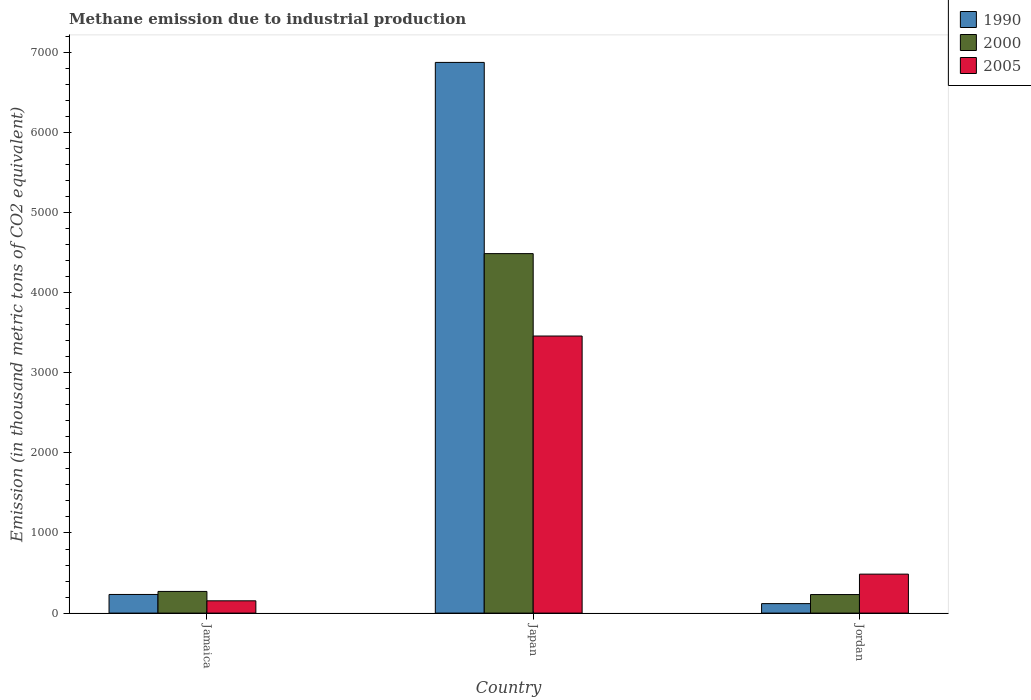How many different coloured bars are there?
Provide a short and direct response. 3. How many groups of bars are there?
Your answer should be compact. 3. How many bars are there on the 1st tick from the left?
Provide a succinct answer. 3. How many bars are there on the 1st tick from the right?
Offer a very short reply. 3. What is the label of the 1st group of bars from the left?
Your answer should be compact. Jamaica. What is the amount of methane emitted in 2000 in Jamaica?
Offer a very short reply. 270.4. Across all countries, what is the maximum amount of methane emitted in 1990?
Ensure brevity in your answer.  6873.6. Across all countries, what is the minimum amount of methane emitted in 2000?
Offer a terse response. 231.4. In which country was the amount of methane emitted in 2005 minimum?
Offer a terse response. Jamaica. What is the total amount of methane emitted in 2000 in the graph?
Ensure brevity in your answer.  4988.7. What is the difference between the amount of methane emitted in 2000 in Japan and that in Jordan?
Your answer should be compact. 4255.5. What is the difference between the amount of methane emitted in 1990 in Jordan and the amount of methane emitted in 2005 in Japan?
Make the answer very short. -3339.9. What is the average amount of methane emitted in 2005 per country?
Offer a very short reply. 1365.97. What is the difference between the amount of methane emitted of/in 2005 and amount of methane emitted of/in 1990 in Japan?
Your response must be concise. -3415.3. What is the ratio of the amount of methane emitted in 1990 in Jamaica to that in Japan?
Your answer should be very brief. 0.03. What is the difference between the highest and the second highest amount of methane emitted in 2000?
Make the answer very short. -4255.5. What is the difference between the highest and the lowest amount of methane emitted in 1990?
Provide a short and direct response. 6755.2. How many bars are there?
Your answer should be compact. 9. Are all the bars in the graph horizontal?
Ensure brevity in your answer.  No. How many countries are there in the graph?
Keep it short and to the point. 3. Does the graph contain grids?
Your response must be concise. No. Where does the legend appear in the graph?
Ensure brevity in your answer.  Top right. How many legend labels are there?
Give a very brief answer. 3. What is the title of the graph?
Ensure brevity in your answer.  Methane emission due to industrial production. Does "2014" appear as one of the legend labels in the graph?
Your response must be concise. No. What is the label or title of the Y-axis?
Ensure brevity in your answer.  Emission (in thousand metric tons of CO2 equivalent). What is the Emission (in thousand metric tons of CO2 equivalent) in 1990 in Jamaica?
Offer a terse response. 232.7. What is the Emission (in thousand metric tons of CO2 equivalent) of 2000 in Jamaica?
Provide a succinct answer. 270.4. What is the Emission (in thousand metric tons of CO2 equivalent) of 2005 in Jamaica?
Make the answer very short. 153.3. What is the Emission (in thousand metric tons of CO2 equivalent) in 1990 in Japan?
Your response must be concise. 6873.6. What is the Emission (in thousand metric tons of CO2 equivalent) in 2000 in Japan?
Your response must be concise. 4486.9. What is the Emission (in thousand metric tons of CO2 equivalent) of 2005 in Japan?
Your answer should be very brief. 3458.3. What is the Emission (in thousand metric tons of CO2 equivalent) of 1990 in Jordan?
Offer a very short reply. 118.4. What is the Emission (in thousand metric tons of CO2 equivalent) of 2000 in Jordan?
Your answer should be compact. 231.4. What is the Emission (in thousand metric tons of CO2 equivalent) of 2005 in Jordan?
Your answer should be very brief. 486.3. Across all countries, what is the maximum Emission (in thousand metric tons of CO2 equivalent) of 1990?
Provide a short and direct response. 6873.6. Across all countries, what is the maximum Emission (in thousand metric tons of CO2 equivalent) in 2000?
Offer a very short reply. 4486.9. Across all countries, what is the maximum Emission (in thousand metric tons of CO2 equivalent) of 2005?
Ensure brevity in your answer.  3458.3. Across all countries, what is the minimum Emission (in thousand metric tons of CO2 equivalent) in 1990?
Ensure brevity in your answer.  118.4. Across all countries, what is the minimum Emission (in thousand metric tons of CO2 equivalent) of 2000?
Your response must be concise. 231.4. Across all countries, what is the minimum Emission (in thousand metric tons of CO2 equivalent) of 2005?
Give a very brief answer. 153.3. What is the total Emission (in thousand metric tons of CO2 equivalent) of 1990 in the graph?
Ensure brevity in your answer.  7224.7. What is the total Emission (in thousand metric tons of CO2 equivalent) in 2000 in the graph?
Offer a very short reply. 4988.7. What is the total Emission (in thousand metric tons of CO2 equivalent) of 2005 in the graph?
Ensure brevity in your answer.  4097.9. What is the difference between the Emission (in thousand metric tons of CO2 equivalent) of 1990 in Jamaica and that in Japan?
Your answer should be compact. -6640.9. What is the difference between the Emission (in thousand metric tons of CO2 equivalent) in 2000 in Jamaica and that in Japan?
Keep it short and to the point. -4216.5. What is the difference between the Emission (in thousand metric tons of CO2 equivalent) in 2005 in Jamaica and that in Japan?
Keep it short and to the point. -3305. What is the difference between the Emission (in thousand metric tons of CO2 equivalent) in 1990 in Jamaica and that in Jordan?
Ensure brevity in your answer.  114.3. What is the difference between the Emission (in thousand metric tons of CO2 equivalent) of 2000 in Jamaica and that in Jordan?
Keep it short and to the point. 39. What is the difference between the Emission (in thousand metric tons of CO2 equivalent) of 2005 in Jamaica and that in Jordan?
Your response must be concise. -333. What is the difference between the Emission (in thousand metric tons of CO2 equivalent) of 1990 in Japan and that in Jordan?
Provide a short and direct response. 6755.2. What is the difference between the Emission (in thousand metric tons of CO2 equivalent) in 2000 in Japan and that in Jordan?
Offer a terse response. 4255.5. What is the difference between the Emission (in thousand metric tons of CO2 equivalent) in 2005 in Japan and that in Jordan?
Ensure brevity in your answer.  2972. What is the difference between the Emission (in thousand metric tons of CO2 equivalent) in 1990 in Jamaica and the Emission (in thousand metric tons of CO2 equivalent) in 2000 in Japan?
Make the answer very short. -4254.2. What is the difference between the Emission (in thousand metric tons of CO2 equivalent) in 1990 in Jamaica and the Emission (in thousand metric tons of CO2 equivalent) in 2005 in Japan?
Your response must be concise. -3225.6. What is the difference between the Emission (in thousand metric tons of CO2 equivalent) of 2000 in Jamaica and the Emission (in thousand metric tons of CO2 equivalent) of 2005 in Japan?
Give a very brief answer. -3187.9. What is the difference between the Emission (in thousand metric tons of CO2 equivalent) of 1990 in Jamaica and the Emission (in thousand metric tons of CO2 equivalent) of 2000 in Jordan?
Your response must be concise. 1.3. What is the difference between the Emission (in thousand metric tons of CO2 equivalent) in 1990 in Jamaica and the Emission (in thousand metric tons of CO2 equivalent) in 2005 in Jordan?
Provide a succinct answer. -253.6. What is the difference between the Emission (in thousand metric tons of CO2 equivalent) in 2000 in Jamaica and the Emission (in thousand metric tons of CO2 equivalent) in 2005 in Jordan?
Ensure brevity in your answer.  -215.9. What is the difference between the Emission (in thousand metric tons of CO2 equivalent) in 1990 in Japan and the Emission (in thousand metric tons of CO2 equivalent) in 2000 in Jordan?
Your response must be concise. 6642.2. What is the difference between the Emission (in thousand metric tons of CO2 equivalent) in 1990 in Japan and the Emission (in thousand metric tons of CO2 equivalent) in 2005 in Jordan?
Provide a succinct answer. 6387.3. What is the difference between the Emission (in thousand metric tons of CO2 equivalent) in 2000 in Japan and the Emission (in thousand metric tons of CO2 equivalent) in 2005 in Jordan?
Offer a very short reply. 4000.6. What is the average Emission (in thousand metric tons of CO2 equivalent) in 1990 per country?
Give a very brief answer. 2408.23. What is the average Emission (in thousand metric tons of CO2 equivalent) in 2000 per country?
Ensure brevity in your answer.  1662.9. What is the average Emission (in thousand metric tons of CO2 equivalent) in 2005 per country?
Provide a succinct answer. 1365.97. What is the difference between the Emission (in thousand metric tons of CO2 equivalent) in 1990 and Emission (in thousand metric tons of CO2 equivalent) in 2000 in Jamaica?
Offer a very short reply. -37.7. What is the difference between the Emission (in thousand metric tons of CO2 equivalent) in 1990 and Emission (in thousand metric tons of CO2 equivalent) in 2005 in Jamaica?
Make the answer very short. 79.4. What is the difference between the Emission (in thousand metric tons of CO2 equivalent) of 2000 and Emission (in thousand metric tons of CO2 equivalent) of 2005 in Jamaica?
Your response must be concise. 117.1. What is the difference between the Emission (in thousand metric tons of CO2 equivalent) in 1990 and Emission (in thousand metric tons of CO2 equivalent) in 2000 in Japan?
Give a very brief answer. 2386.7. What is the difference between the Emission (in thousand metric tons of CO2 equivalent) of 1990 and Emission (in thousand metric tons of CO2 equivalent) of 2005 in Japan?
Give a very brief answer. 3415.3. What is the difference between the Emission (in thousand metric tons of CO2 equivalent) of 2000 and Emission (in thousand metric tons of CO2 equivalent) of 2005 in Japan?
Your response must be concise. 1028.6. What is the difference between the Emission (in thousand metric tons of CO2 equivalent) of 1990 and Emission (in thousand metric tons of CO2 equivalent) of 2000 in Jordan?
Your answer should be compact. -113. What is the difference between the Emission (in thousand metric tons of CO2 equivalent) in 1990 and Emission (in thousand metric tons of CO2 equivalent) in 2005 in Jordan?
Provide a short and direct response. -367.9. What is the difference between the Emission (in thousand metric tons of CO2 equivalent) in 2000 and Emission (in thousand metric tons of CO2 equivalent) in 2005 in Jordan?
Offer a very short reply. -254.9. What is the ratio of the Emission (in thousand metric tons of CO2 equivalent) of 1990 in Jamaica to that in Japan?
Ensure brevity in your answer.  0.03. What is the ratio of the Emission (in thousand metric tons of CO2 equivalent) in 2000 in Jamaica to that in Japan?
Ensure brevity in your answer.  0.06. What is the ratio of the Emission (in thousand metric tons of CO2 equivalent) in 2005 in Jamaica to that in Japan?
Keep it short and to the point. 0.04. What is the ratio of the Emission (in thousand metric tons of CO2 equivalent) of 1990 in Jamaica to that in Jordan?
Make the answer very short. 1.97. What is the ratio of the Emission (in thousand metric tons of CO2 equivalent) of 2000 in Jamaica to that in Jordan?
Offer a terse response. 1.17. What is the ratio of the Emission (in thousand metric tons of CO2 equivalent) of 2005 in Jamaica to that in Jordan?
Your answer should be very brief. 0.32. What is the ratio of the Emission (in thousand metric tons of CO2 equivalent) of 1990 in Japan to that in Jordan?
Your answer should be compact. 58.05. What is the ratio of the Emission (in thousand metric tons of CO2 equivalent) of 2000 in Japan to that in Jordan?
Keep it short and to the point. 19.39. What is the ratio of the Emission (in thousand metric tons of CO2 equivalent) of 2005 in Japan to that in Jordan?
Offer a terse response. 7.11. What is the difference between the highest and the second highest Emission (in thousand metric tons of CO2 equivalent) of 1990?
Your answer should be compact. 6640.9. What is the difference between the highest and the second highest Emission (in thousand metric tons of CO2 equivalent) of 2000?
Provide a succinct answer. 4216.5. What is the difference between the highest and the second highest Emission (in thousand metric tons of CO2 equivalent) in 2005?
Ensure brevity in your answer.  2972. What is the difference between the highest and the lowest Emission (in thousand metric tons of CO2 equivalent) in 1990?
Ensure brevity in your answer.  6755.2. What is the difference between the highest and the lowest Emission (in thousand metric tons of CO2 equivalent) in 2000?
Ensure brevity in your answer.  4255.5. What is the difference between the highest and the lowest Emission (in thousand metric tons of CO2 equivalent) in 2005?
Your answer should be compact. 3305. 